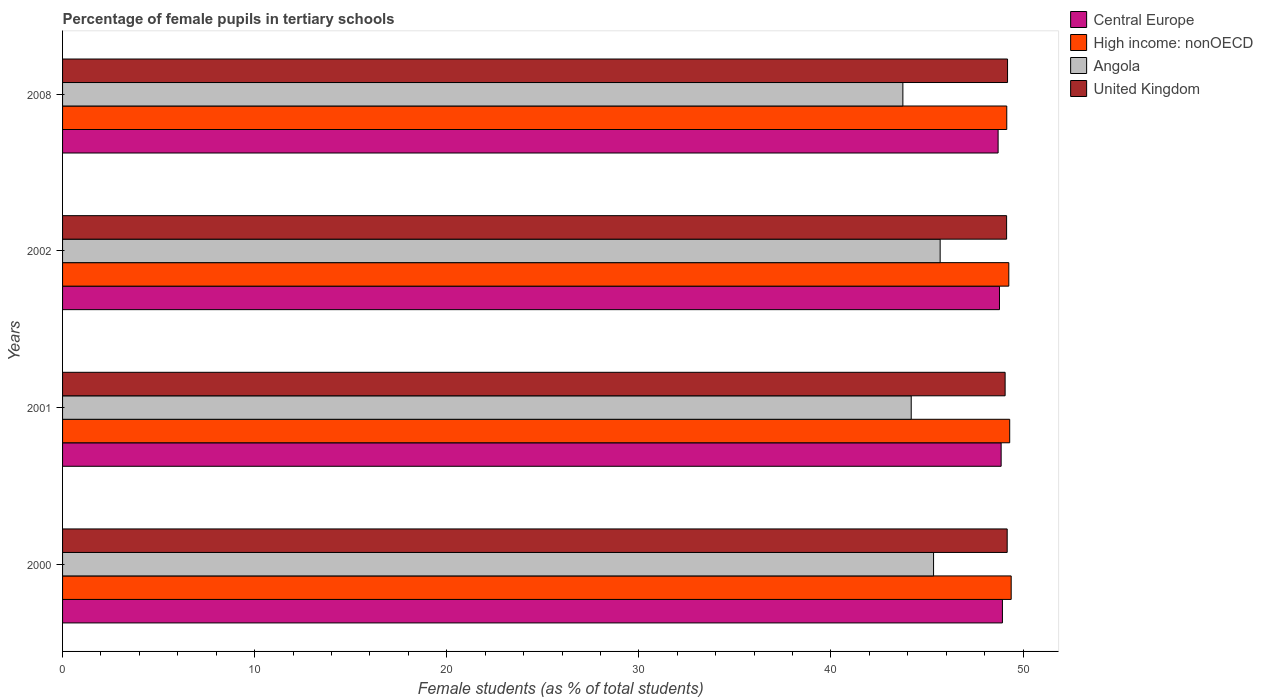How many different coloured bars are there?
Ensure brevity in your answer.  4. How many bars are there on the 1st tick from the top?
Give a very brief answer. 4. In how many cases, is the number of bars for a given year not equal to the number of legend labels?
Keep it short and to the point. 0. What is the percentage of female pupils in tertiary schools in Angola in 2008?
Keep it short and to the point. 43.75. Across all years, what is the maximum percentage of female pupils in tertiary schools in Angola?
Provide a short and direct response. 45.69. Across all years, what is the minimum percentage of female pupils in tertiary schools in United Kingdom?
Offer a very short reply. 49.07. In which year was the percentage of female pupils in tertiary schools in Central Europe maximum?
Make the answer very short. 2000. What is the total percentage of female pupils in tertiary schools in High income: nonOECD in the graph?
Provide a succinct answer. 197.11. What is the difference between the percentage of female pupils in tertiary schools in High income: nonOECD in 2000 and that in 2001?
Your answer should be compact. 0.08. What is the difference between the percentage of female pupils in tertiary schools in United Kingdom in 2000 and the percentage of female pupils in tertiary schools in Central Europe in 2008?
Your answer should be very brief. 0.47. What is the average percentage of female pupils in tertiary schools in Angola per year?
Keep it short and to the point. 44.74. In the year 2002, what is the difference between the percentage of female pupils in tertiary schools in Angola and percentage of female pupils in tertiary schools in United Kingdom?
Your answer should be very brief. -3.46. In how many years, is the percentage of female pupils in tertiary schools in High income: nonOECD greater than 22 %?
Make the answer very short. 4. What is the ratio of the percentage of female pupils in tertiary schools in Angola in 2000 to that in 2008?
Your response must be concise. 1.04. Is the percentage of female pupils in tertiary schools in Angola in 2000 less than that in 2008?
Offer a very short reply. No. Is the difference between the percentage of female pupils in tertiary schools in Angola in 2002 and 2008 greater than the difference between the percentage of female pupils in tertiary schools in United Kingdom in 2002 and 2008?
Keep it short and to the point. Yes. What is the difference between the highest and the second highest percentage of female pupils in tertiary schools in United Kingdom?
Make the answer very short. 0.02. What is the difference between the highest and the lowest percentage of female pupils in tertiary schools in Angola?
Your response must be concise. 1.94. In how many years, is the percentage of female pupils in tertiary schools in Angola greater than the average percentage of female pupils in tertiary schools in Angola taken over all years?
Make the answer very short. 2. What does the 2nd bar from the top in 2002 represents?
Offer a terse response. Angola. What does the 1st bar from the bottom in 2000 represents?
Offer a very short reply. Central Europe. What is the difference between two consecutive major ticks on the X-axis?
Provide a succinct answer. 10. Are the values on the major ticks of X-axis written in scientific E-notation?
Provide a short and direct response. No. Does the graph contain any zero values?
Provide a succinct answer. No. Where does the legend appear in the graph?
Your response must be concise. Top right. What is the title of the graph?
Give a very brief answer. Percentage of female pupils in tertiary schools. What is the label or title of the X-axis?
Offer a very short reply. Female students (as % of total students). What is the Female students (as % of total students) in Central Europe in 2000?
Give a very brief answer. 48.93. What is the Female students (as % of total students) in High income: nonOECD in 2000?
Your answer should be very brief. 49.38. What is the Female students (as % of total students) of Angola in 2000?
Give a very brief answer. 45.34. What is the Female students (as % of total students) of United Kingdom in 2000?
Your response must be concise. 49.18. What is the Female students (as % of total students) in Central Europe in 2001?
Offer a terse response. 48.86. What is the Female students (as % of total students) in High income: nonOECD in 2001?
Ensure brevity in your answer.  49.31. What is the Female students (as % of total students) of Angola in 2001?
Offer a terse response. 44.18. What is the Female students (as % of total students) in United Kingdom in 2001?
Keep it short and to the point. 49.07. What is the Female students (as % of total students) in Central Europe in 2002?
Provide a succinct answer. 48.78. What is the Female students (as % of total students) of High income: nonOECD in 2002?
Give a very brief answer. 49.26. What is the Female students (as % of total students) in Angola in 2002?
Your answer should be compact. 45.69. What is the Female students (as % of total students) of United Kingdom in 2002?
Your answer should be compact. 49.15. What is the Female students (as % of total students) of Central Europe in 2008?
Ensure brevity in your answer.  48.7. What is the Female students (as % of total students) in High income: nonOECD in 2008?
Give a very brief answer. 49.15. What is the Female students (as % of total students) of Angola in 2008?
Ensure brevity in your answer.  43.75. What is the Female students (as % of total students) in United Kingdom in 2008?
Make the answer very short. 49.19. Across all years, what is the maximum Female students (as % of total students) in Central Europe?
Ensure brevity in your answer.  48.93. Across all years, what is the maximum Female students (as % of total students) in High income: nonOECD?
Your response must be concise. 49.38. Across all years, what is the maximum Female students (as % of total students) of Angola?
Your response must be concise. 45.69. Across all years, what is the maximum Female students (as % of total students) in United Kingdom?
Your response must be concise. 49.19. Across all years, what is the minimum Female students (as % of total students) of Central Europe?
Make the answer very short. 48.7. Across all years, what is the minimum Female students (as % of total students) in High income: nonOECD?
Ensure brevity in your answer.  49.15. Across all years, what is the minimum Female students (as % of total students) in Angola?
Provide a short and direct response. 43.75. Across all years, what is the minimum Female students (as % of total students) in United Kingdom?
Give a very brief answer. 49.07. What is the total Female students (as % of total students) in Central Europe in the graph?
Ensure brevity in your answer.  195.27. What is the total Female students (as % of total students) of High income: nonOECD in the graph?
Offer a terse response. 197.11. What is the total Female students (as % of total students) in Angola in the graph?
Your answer should be very brief. 178.96. What is the total Female students (as % of total students) of United Kingdom in the graph?
Your answer should be compact. 196.59. What is the difference between the Female students (as % of total students) in Central Europe in 2000 and that in 2001?
Give a very brief answer. 0.07. What is the difference between the Female students (as % of total students) in High income: nonOECD in 2000 and that in 2001?
Give a very brief answer. 0.08. What is the difference between the Female students (as % of total students) of Angola in 2000 and that in 2001?
Your answer should be compact. 1.16. What is the difference between the Female students (as % of total students) of United Kingdom in 2000 and that in 2001?
Make the answer very short. 0.11. What is the difference between the Female students (as % of total students) of Central Europe in 2000 and that in 2002?
Your answer should be compact. 0.15. What is the difference between the Female students (as % of total students) in High income: nonOECD in 2000 and that in 2002?
Give a very brief answer. 0.12. What is the difference between the Female students (as % of total students) in Angola in 2000 and that in 2002?
Your response must be concise. -0.34. What is the difference between the Female students (as % of total students) in United Kingdom in 2000 and that in 2002?
Ensure brevity in your answer.  0.03. What is the difference between the Female students (as % of total students) in Central Europe in 2000 and that in 2008?
Your response must be concise. 0.22. What is the difference between the Female students (as % of total students) in High income: nonOECD in 2000 and that in 2008?
Your answer should be compact. 0.23. What is the difference between the Female students (as % of total students) of Angola in 2000 and that in 2008?
Keep it short and to the point. 1.6. What is the difference between the Female students (as % of total students) of United Kingdom in 2000 and that in 2008?
Offer a terse response. -0.02. What is the difference between the Female students (as % of total students) of Central Europe in 2001 and that in 2002?
Provide a short and direct response. 0.09. What is the difference between the Female students (as % of total students) of High income: nonOECD in 2001 and that in 2002?
Make the answer very short. 0.05. What is the difference between the Female students (as % of total students) in Angola in 2001 and that in 2002?
Your answer should be very brief. -1.51. What is the difference between the Female students (as % of total students) of United Kingdom in 2001 and that in 2002?
Offer a terse response. -0.08. What is the difference between the Female students (as % of total students) in Central Europe in 2001 and that in 2008?
Provide a succinct answer. 0.16. What is the difference between the Female students (as % of total students) of High income: nonOECD in 2001 and that in 2008?
Give a very brief answer. 0.15. What is the difference between the Female students (as % of total students) of Angola in 2001 and that in 2008?
Make the answer very short. 0.43. What is the difference between the Female students (as % of total students) in United Kingdom in 2001 and that in 2008?
Provide a succinct answer. -0.13. What is the difference between the Female students (as % of total students) of Central Europe in 2002 and that in 2008?
Make the answer very short. 0.07. What is the difference between the Female students (as % of total students) of High income: nonOECD in 2002 and that in 2008?
Make the answer very short. 0.11. What is the difference between the Female students (as % of total students) in Angola in 2002 and that in 2008?
Give a very brief answer. 1.94. What is the difference between the Female students (as % of total students) in United Kingdom in 2002 and that in 2008?
Keep it short and to the point. -0.05. What is the difference between the Female students (as % of total students) in Central Europe in 2000 and the Female students (as % of total students) in High income: nonOECD in 2001?
Your answer should be compact. -0.38. What is the difference between the Female students (as % of total students) of Central Europe in 2000 and the Female students (as % of total students) of Angola in 2001?
Your answer should be compact. 4.75. What is the difference between the Female students (as % of total students) in Central Europe in 2000 and the Female students (as % of total students) in United Kingdom in 2001?
Offer a very short reply. -0.14. What is the difference between the Female students (as % of total students) in High income: nonOECD in 2000 and the Female students (as % of total students) in Angola in 2001?
Make the answer very short. 5.2. What is the difference between the Female students (as % of total students) of High income: nonOECD in 2000 and the Female students (as % of total students) of United Kingdom in 2001?
Offer a very short reply. 0.32. What is the difference between the Female students (as % of total students) in Angola in 2000 and the Female students (as % of total students) in United Kingdom in 2001?
Provide a short and direct response. -3.73. What is the difference between the Female students (as % of total students) of Central Europe in 2000 and the Female students (as % of total students) of High income: nonOECD in 2002?
Give a very brief answer. -0.33. What is the difference between the Female students (as % of total students) in Central Europe in 2000 and the Female students (as % of total students) in Angola in 2002?
Make the answer very short. 3.24. What is the difference between the Female students (as % of total students) in Central Europe in 2000 and the Female students (as % of total students) in United Kingdom in 2002?
Your response must be concise. -0.22. What is the difference between the Female students (as % of total students) of High income: nonOECD in 2000 and the Female students (as % of total students) of Angola in 2002?
Your answer should be very brief. 3.7. What is the difference between the Female students (as % of total students) of High income: nonOECD in 2000 and the Female students (as % of total students) of United Kingdom in 2002?
Your answer should be compact. 0.24. What is the difference between the Female students (as % of total students) in Angola in 2000 and the Female students (as % of total students) in United Kingdom in 2002?
Keep it short and to the point. -3.8. What is the difference between the Female students (as % of total students) of Central Europe in 2000 and the Female students (as % of total students) of High income: nonOECD in 2008?
Keep it short and to the point. -0.23. What is the difference between the Female students (as % of total students) in Central Europe in 2000 and the Female students (as % of total students) in Angola in 2008?
Provide a short and direct response. 5.18. What is the difference between the Female students (as % of total students) of Central Europe in 2000 and the Female students (as % of total students) of United Kingdom in 2008?
Offer a very short reply. -0.27. What is the difference between the Female students (as % of total students) in High income: nonOECD in 2000 and the Female students (as % of total students) in Angola in 2008?
Your answer should be compact. 5.64. What is the difference between the Female students (as % of total students) of High income: nonOECD in 2000 and the Female students (as % of total students) of United Kingdom in 2008?
Provide a succinct answer. 0.19. What is the difference between the Female students (as % of total students) of Angola in 2000 and the Female students (as % of total students) of United Kingdom in 2008?
Your response must be concise. -3.85. What is the difference between the Female students (as % of total students) of Central Europe in 2001 and the Female students (as % of total students) of High income: nonOECD in 2002?
Give a very brief answer. -0.4. What is the difference between the Female students (as % of total students) of Central Europe in 2001 and the Female students (as % of total students) of Angola in 2002?
Offer a very short reply. 3.17. What is the difference between the Female students (as % of total students) of Central Europe in 2001 and the Female students (as % of total students) of United Kingdom in 2002?
Ensure brevity in your answer.  -0.28. What is the difference between the Female students (as % of total students) of High income: nonOECD in 2001 and the Female students (as % of total students) of Angola in 2002?
Provide a short and direct response. 3.62. What is the difference between the Female students (as % of total students) of High income: nonOECD in 2001 and the Female students (as % of total students) of United Kingdom in 2002?
Your answer should be very brief. 0.16. What is the difference between the Female students (as % of total students) of Angola in 2001 and the Female students (as % of total students) of United Kingdom in 2002?
Ensure brevity in your answer.  -4.97. What is the difference between the Female students (as % of total students) in Central Europe in 2001 and the Female students (as % of total students) in High income: nonOECD in 2008?
Provide a succinct answer. -0.29. What is the difference between the Female students (as % of total students) in Central Europe in 2001 and the Female students (as % of total students) in Angola in 2008?
Your response must be concise. 5.12. What is the difference between the Female students (as % of total students) in Central Europe in 2001 and the Female students (as % of total students) in United Kingdom in 2008?
Keep it short and to the point. -0.33. What is the difference between the Female students (as % of total students) of High income: nonOECD in 2001 and the Female students (as % of total students) of Angola in 2008?
Your answer should be very brief. 5.56. What is the difference between the Female students (as % of total students) in High income: nonOECD in 2001 and the Female students (as % of total students) in United Kingdom in 2008?
Your answer should be compact. 0.11. What is the difference between the Female students (as % of total students) in Angola in 2001 and the Female students (as % of total students) in United Kingdom in 2008?
Offer a very short reply. -5.01. What is the difference between the Female students (as % of total students) in Central Europe in 2002 and the Female students (as % of total students) in High income: nonOECD in 2008?
Make the answer very short. -0.38. What is the difference between the Female students (as % of total students) in Central Europe in 2002 and the Female students (as % of total students) in Angola in 2008?
Keep it short and to the point. 5.03. What is the difference between the Female students (as % of total students) of Central Europe in 2002 and the Female students (as % of total students) of United Kingdom in 2008?
Offer a very short reply. -0.42. What is the difference between the Female students (as % of total students) in High income: nonOECD in 2002 and the Female students (as % of total students) in Angola in 2008?
Offer a terse response. 5.52. What is the difference between the Female students (as % of total students) in High income: nonOECD in 2002 and the Female students (as % of total students) in United Kingdom in 2008?
Provide a succinct answer. 0.07. What is the difference between the Female students (as % of total students) of Angola in 2002 and the Female students (as % of total students) of United Kingdom in 2008?
Offer a terse response. -3.51. What is the average Female students (as % of total students) of Central Europe per year?
Your response must be concise. 48.82. What is the average Female students (as % of total students) of High income: nonOECD per year?
Your answer should be compact. 49.28. What is the average Female students (as % of total students) in Angola per year?
Keep it short and to the point. 44.74. What is the average Female students (as % of total students) of United Kingdom per year?
Ensure brevity in your answer.  49.15. In the year 2000, what is the difference between the Female students (as % of total students) in Central Europe and Female students (as % of total students) in High income: nonOECD?
Give a very brief answer. -0.46. In the year 2000, what is the difference between the Female students (as % of total students) of Central Europe and Female students (as % of total students) of Angola?
Your answer should be compact. 3.58. In the year 2000, what is the difference between the Female students (as % of total students) of Central Europe and Female students (as % of total students) of United Kingdom?
Your response must be concise. -0.25. In the year 2000, what is the difference between the Female students (as % of total students) in High income: nonOECD and Female students (as % of total students) in Angola?
Give a very brief answer. 4.04. In the year 2000, what is the difference between the Female students (as % of total students) of High income: nonOECD and Female students (as % of total students) of United Kingdom?
Ensure brevity in your answer.  0.21. In the year 2000, what is the difference between the Female students (as % of total students) of Angola and Female students (as % of total students) of United Kingdom?
Keep it short and to the point. -3.83. In the year 2001, what is the difference between the Female students (as % of total students) of Central Europe and Female students (as % of total students) of High income: nonOECD?
Offer a very short reply. -0.45. In the year 2001, what is the difference between the Female students (as % of total students) of Central Europe and Female students (as % of total students) of Angola?
Offer a terse response. 4.68. In the year 2001, what is the difference between the Female students (as % of total students) of Central Europe and Female students (as % of total students) of United Kingdom?
Keep it short and to the point. -0.21. In the year 2001, what is the difference between the Female students (as % of total students) of High income: nonOECD and Female students (as % of total students) of Angola?
Your answer should be very brief. 5.13. In the year 2001, what is the difference between the Female students (as % of total students) in High income: nonOECD and Female students (as % of total students) in United Kingdom?
Offer a terse response. 0.24. In the year 2001, what is the difference between the Female students (as % of total students) in Angola and Female students (as % of total students) in United Kingdom?
Provide a succinct answer. -4.89. In the year 2002, what is the difference between the Female students (as % of total students) in Central Europe and Female students (as % of total students) in High income: nonOECD?
Make the answer very short. -0.49. In the year 2002, what is the difference between the Female students (as % of total students) in Central Europe and Female students (as % of total students) in Angola?
Keep it short and to the point. 3.09. In the year 2002, what is the difference between the Female students (as % of total students) in Central Europe and Female students (as % of total students) in United Kingdom?
Make the answer very short. -0.37. In the year 2002, what is the difference between the Female students (as % of total students) of High income: nonOECD and Female students (as % of total students) of Angola?
Keep it short and to the point. 3.57. In the year 2002, what is the difference between the Female students (as % of total students) in High income: nonOECD and Female students (as % of total students) in United Kingdom?
Keep it short and to the point. 0.12. In the year 2002, what is the difference between the Female students (as % of total students) of Angola and Female students (as % of total students) of United Kingdom?
Your response must be concise. -3.46. In the year 2008, what is the difference between the Female students (as % of total students) in Central Europe and Female students (as % of total students) in High income: nonOECD?
Your answer should be very brief. -0.45. In the year 2008, what is the difference between the Female students (as % of total students) in Central Europe and Female students (as % of total students) in Angola?
Give a very brief answer. 4.96. In the year 2008, what is the difference between the Female students (as % of total students) of Central Europe and Female students (as % of total students) of United Kingdom?
Provide a short and direct response. -0.49. In the year 2008, what is the difference between the Female students (as % of total students) in High income: nonOECD and Female students (as % of total students) in Angola?
Ensure brevity in your answer.  5.41. In the year 2008, what is the difference between the Female students (as % of total students) of High income: nonOECD and Female students (as % of total students) of United Kingdom?
Provide a succinct answer. -0.04. In the year 2008, what is the difference between the Female students (as % of total students) in Angola and Female students (as % of total students) in United Kingdom?
Your answer should be compact. -5.45. What is the ratio of the Female students (as % of total students) in Central Europe in 2000 to that in 2001?
Ensure brevity in your answer.  1. What is the ratio of the Female students (as % of total students) in High income: nonOECD in 2000 to that in 2001?
Your answer should be very brief. 1. What is the ratio of the Female students (as % of total students) in Angola in 2000 to that in 2001?
Give a very brief answer. 1.03. What is the ratio of the Female students (as % of total students) in United Kingdom in 2000 to that in 2001?
Provide a short and direct response. 1. What is the ratio of the Female students (as % of total students) in United Kingdom in 2000 to that in 2002?
Your answer should be compact. 1. What is the ratio of the Female students (as % of total students) in High income: nonOECD in 2000 to that in 2008?
Ensure brevity in your answer.  1. What is the ratio of the Female students (as % of total students) of Angola in 2000 to that in 2008?
Your answer should be compact. 1.04. What is the ratio of the Female students (as % of total students) of United Kingdom in 2000 to that in 2008?
Provide a succinct answer. 1. What is the ratio of the Female students (as % of total students) of Central Europe in 2001 to that in 2002?
Offer a terse response. 1. What is the ratio of the Female students (as % of total students) of High income: nonOECD in 2001 to that in 2002?
Your answer should be compact. 1. What is the ratio of the Female students (as % of total students) in High income: nonOECD in 2001 to that in 2008?
Offer a very short reply. 1. What is the ratio of the Female students (as % of total students) of Angola in 2001 to that in 2008?
Give a very brief answer. 1.01. What is the ratio of the Female students (as % of total students) in Central Europe in 2002 to that in 2008?
Your answer should be compact. 1. What is the ratio of the Female students (as % of total students) of Angola in 2002 to that in 2008?
Offer a very short reply. 1.04. What is the difference between the highest and the second highest Female students (as % of total students) of Central Europe?
Your answer should be very brief. 0.07. What is the difference between the highest and the second highest Female students (as % of total students) of High income: nonOECD?
Provide a succinct answer. 0.08. What is the difference between the highest and the second highest Female students (as % of total students) of Angola?
Make the answer very short. 0.34. What is the difference between the highest and the second highest Female students (as % of total students) in United Kingdom?
Make the answer very short. 0.02. What is the difference between the highest and the lowest Female students (as % of total students) in Central Europe?
Make the answer very short. 0.22. What is the difference between the highest and the lowest Female students (as % of total students) in High income: nonOECD?
Provide a succinct answer. 0.23. What is the difference between the highest and the lowest Female students (as % of total students) of Angola?
Offer a terse response. 1.94. What is the difference between the highest and the lowest Female students (as % of total students) in United Kingdom?
Keep it short and to the point. 0.13. 